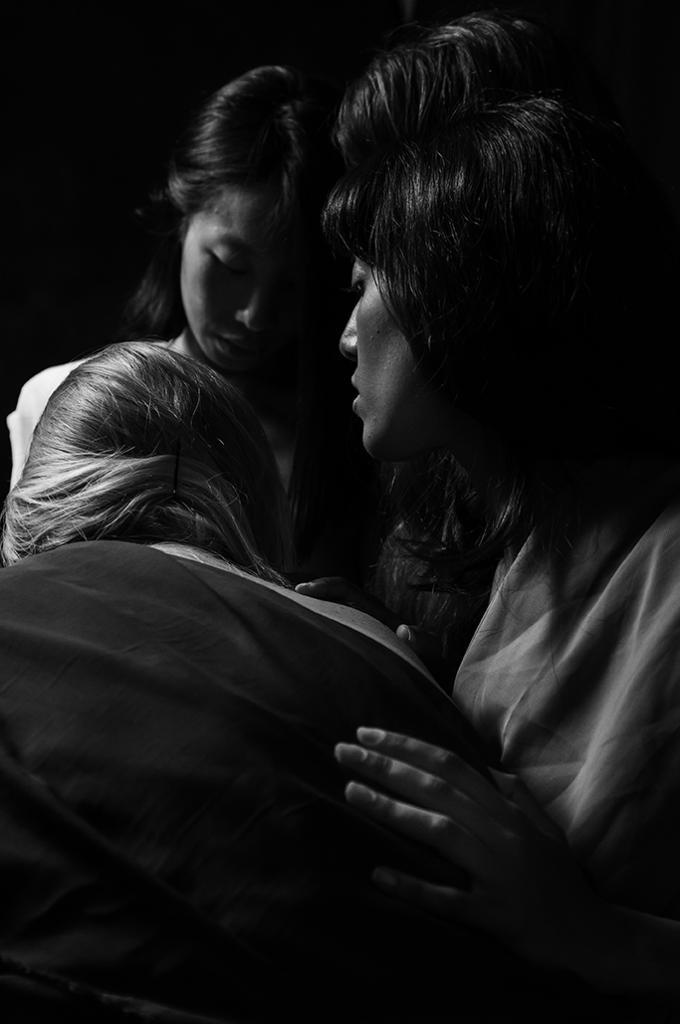What is the color scheme of the image? The image is black and white. How many people are in the image? There are three people standing in the image. What can be seen in the background of the image? The background of the image is dark. Where is the faucet located in the image? There is no faucet present in the image. What is the limit or boundary of the image? The image itself does not have a limit or boundary, as it is a digital representation of a scene. 